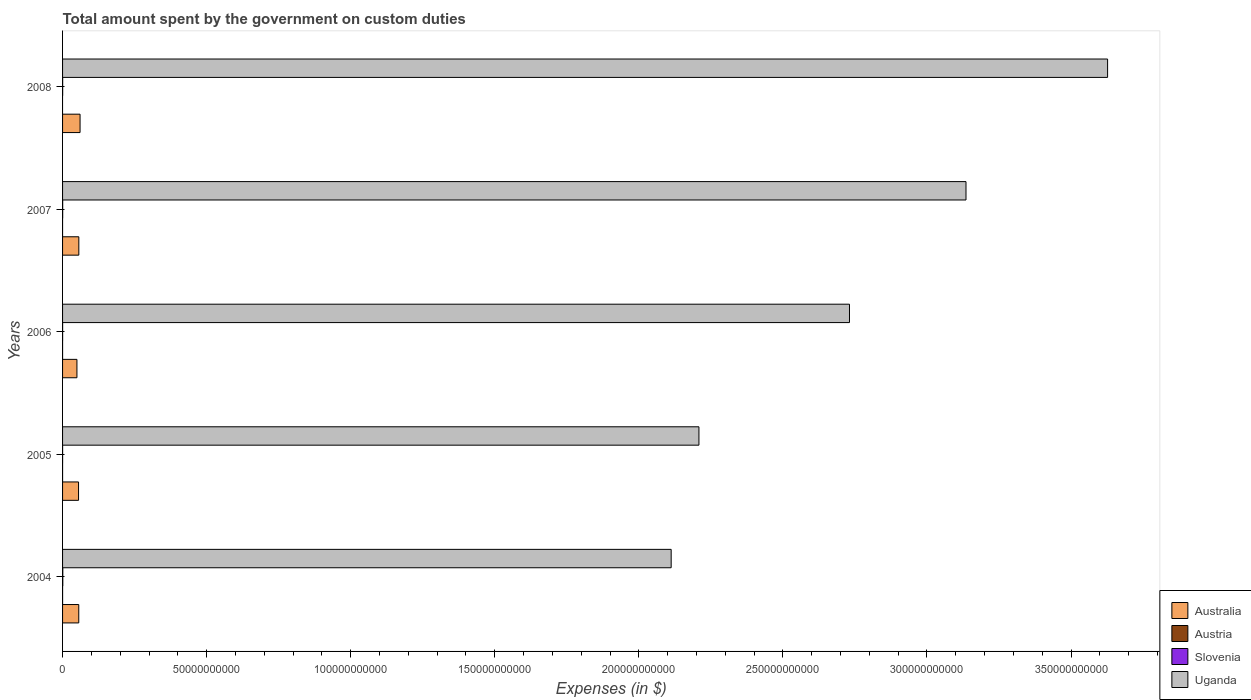Are the number of bars per tick equal to the number of legend labels?
Your response must be concise. No. Are the number of bars on each tick of the Y-axis equal?
Ensure brevity in your answer.  No. How many bars are there on the 3rd tick from the top?
Make the answer very short. 4. How many bars are there on the 3rd tick from the bottom?
Your answer should be compact. 4. What is the label of the 4th group of bars from the top?
Keep it short and to the point. 2005. What is the amount spent on custom duties by the government in Uganda in 2008?
Keep it short and to the point. 3.63e+11. Across all years, what is the maximum amount spent on custom duties by the government in Austria?
Provide a succinct answer. 3.94e+06. Across all years, what is the minimum amount spent on custom duties by the government in Australia?
Your answer should be very brief. 4.99e+09. In which year was the amount spent on custom duties by the government in Uganda maximum?
Keep it short and to the point. 2008. What is the total amount spent on custom duties by the government in Slovenia in the graph?
Your answer should be compact. 1.71e+08. What is the difference between the amount spent on custom duties by the government in Australia in 2004 and that in 2007?
Make the answer very short. -2.20e+07. What is the difference between the amount spent on custom duties by the government in Slovenia in 2006 and the amount spent on custom duties by the government in Australia in 2008?
Ensure brevity in your answer.  -6.05e+09. What is the average amount spent on custom duties by the government in Uganda per year?
Offer a terse response. 2.76e+11. In the year 2005, what is the difference between the amount spent on custom duties by the government in Uganda and amount spent on custom duties by the government in Austria?
Ensure brevity in your answer.  2.21e+11. In how many years, is the amount spent on custom duties by the government in Austria greater than 160000000000 $?
Your response must be concise. 0. What is the ratio of the amount spent on custom duties by the government in Slovenia in 2004 to that in 2005?
Your answer should be very brief. 7.57. Is the amount spent on custom duties by the government in Slovenia in 2004 less than that in 2007?
Your answer should be compact. No. What is the difference between the highest and the second highest amount spent on custom duties by the government in Slovenia?
Ensure brevity in your answer.  4.62e+07. What is the difference between the highest and the lowest amount spent on custom duties by the government in Austria?
Provide a short and direct response. 3.94e+06. In how many years, is the amount spent on custom duties by the government in Austria greater than the average amount spent on custom duties by the government in Austria taken over all years?
Offer a very short reply. 2. Is the sum of the amount spent on custom duties by the government in Uganda in 2005 and 2006 greater than the maximum amount spent on custom duties by the government in Austria across all years?
Offer a terse response. Yes. Is it the case that in every year, the sum of the amount spent on custom duties by the government in Slovenia and amount spent on custom duties by the government in Austria is greater than the amount spent on custom duties by the government in Uganda?
Provide a short and direct response. No. Are the values on the major ticks of X-axis written in scientific E-notation?
Provide a succinct answer. No. How many legend labels are there?
Your answer should be compact. 4. How are the legend labels stacked?
Provide a short and direct response. Vertical. What is the title of the graph?
Your answer should be compact. Total amount spent by the government on custom duties. Does "Solomon Islands" appear as one of the legend labels in the graph?
Provide a short and direct response. No. What is the label or title of the X-axis?
Your response must be concise. Expenses (in $). What is the Expenses (in $) of Australia in 2004?
Offer a very short reply. 5.62e+09. What is the Expenses (in $) of Austria in 2004?
Give a very brief answer. 3.94e+06. What is the Expenses (in $) in Slovenia in 2004?
Provide a succinct answer. 8.07e+07. What is the Expenses (in $) in Uganda in 2004?
Provide a succinct answer. 2.11e+11. What is the Expenses (in $) of Australia in 2005?
Provide a short and direct response. 5.55e+09. What is the Expenses (in $) of Austria in 2005?
Make the answer very short. 1.43e+06. What is the Expenses (in $) of Slovenia in 2005?
Ensure brevity in your answer.  1.07e+07. What is the Expenses (in $) of Uganda in 2005?
Provide a succinct answer. 2.21e+11. What is the Expenses (in $) of Australia in 2006?
Your answer should be very brief. 4.99e+09. What is the Expenses (in $) of Austria in 2006?
Keep it short and to the point. 7.00e+04. What is the Expenses (in $) in Slovenia in 2006?
Offer a terse response. 1.52e+07. What is the Expenses (in $) in Uganda in 2006?
Provide a short and direct response. 2.73e+11. What is the Expenses (in $) in Australia in 2007?
Offer a terse response. 5.64e+09. What is the Expenses (in $) in Slovenia in 2007?
Your answer should be very brief. 3.45e+07. What is the Expenses (in $) in Uganda in 2007?
Offer a very short reply. 3.14e+11. What is the Expenses (in $) in Australia in 2008?
Provide a succinct answer. 6.07e+09. What is the Expenses (in $) of Austria in 2008?
Your response must be concise. 0. What is the Expenses (in $) in Slovenia in 2008?
Give a very brief answer. 3.00e+07. What is the Expenses (in $) of Uganda in 2008?
Offer a terse response. 3.63e+11. Across all years, what is the maximum Expenses (in $) in Australia?
Ensure brevity in your answer.  6.07e+09. Across all years, what is the maximum Expenses (in $) of Austria?
Your answer should be very brief. 3.94e+06. Across all years, what is the maximum Expenses (in $) in Slovenia?
Give a very brief answer. 8.07e+07. Across all years, what is the maximum Expenses (in $) in Uganda?
Make the answer very short. 3.63e+11. Across all years, what is the minimum Expenses (in $) of Australia?
Provide a short and direct response. 4.99e+09. Across all years, what is the minimum Expenses (in $) in Slovenia?
Provide a short and direct response. 1.07e+07. Across all years, what is the minimum Expenses (in $) of Uganda?
Provide a short and direct response. 2.11e+11. What is the total Expenses (in $) of Australia in the graph?
Give a very brief answer. 2.79e+1. What is the total Expenses (in $) of Austria in the graph?
Provide a short and direct response. 5.44e+06. What is the total Expenses (in $) in Slovenia in the graph?
Your answer should be very brief. 1.71e+08. What is the total Expenses (in $) of Uganda in the graph?
Your answer should be compact. 1.38e+12. What is the difference between the Expenses (in $) of Australia in 2004 and that in 2005?
Your answer should be very brief. 7.40e+07. What is the difference between the Expenses (in $) of Austria in 2004 and that in 2005?
Your answer should be compact. 2.51e+06. What is the difference between the Expenses (in $) of Slovenia in 2004 and that in 2005?
Provide a short and direct response. 7.00e+07. What is the difference between the Expenses (in $) of Uganda in 2004 and that in 2005?
Offer a very short reply. -9.64e+09. What is the difference between the Expenses (in $) in Australia in 2004 and that in 2006?
Provide a short and direct response. 6.34e+08. What is the difference between the Expenses (in $) in Austria in 2004 and that in 2006?
Your answer should be very brief. 3.87e+06. What is the difference between the Expenses (in $) in Slovenia in 2004 and that in 2006?
Your answer should be very brief. 6.55e+07. What is the difference between the Expenses (in $) in Uganda in 2004 and that in 2006?
Keep it short and to the point. -6.19e+1. What is the difference between the Expenses (in $) in Australia in 2004 and that in 2007?
Offer a very short reply. -2.20e+07. What is the difference between the Expenses (in $) in Slovenia in 2004 and that in 2007?
Provide a short and direct response. 4.62e+07. What is the difference between the Expenses (in $) in Uganda in 2004 and that in 2007?
Keep it short and to the point. -1.02e+11. What is the difference between the Expenses (in $) in Australia in 2004 and that in 2008?
Offer a terse response. -4.48e+08. What is the difference between the Expenses (in $) in Slovenia in 2004 and that in 2008?
Provide a succinct answer. 5.07e+07. What is the difference between the Expenses (in $) of Uganda in 2004 and that in 2008?
Give a very brief answer. -1.51e+11. What is the difference between the Expenses (in $) in Australia in 2005 and that in 2006?
Keep it short and to the point. 5.60e+08. What is the difference between the Expenses (in $) of Austria in 2005 and that in 2006?
Make the answer very short. 1.36e+06. What is the difference between the Expenses (in $) in Slovenia in 2005 and that in 2006?
Give a very brief answer. -4.50e+06. What is the difference between the Expenses (in $) in Uganda in 2005 and that in 2006?
Your answer should be compact. -5.22e+1. What is the difference between the Expenses (in $) of Australia in 2005 and that in 2007?
Your answer should be very brief. -9.60e+07. What is the difference between the Expenses (in $) in Slovenia in 2005 and that in 2007?
Make the answer very short. -2.39e+07. What is the difference between the Expenses (in $) in Uganda in 2005 and that in 2007?
Your response must be concise. -9.27e+1. What is the difference between the Expenses (in $) of Australia in 2005 and that in 2008?
Provide a succinct answer. -5.22e+08. What is the difference between the Expenses (in $) in Slovenia in 2005 and that in 2008?
Make the answer very short. -1.94e+07. What is the difference between the Expenses (in $) in Uganda in 2005 and that in 2008?
Your response must be concise. -1.42e+11. What is the difference between the Expenses (in $) in Australia in 2006 and that in 2007?
Your answer should be compact. -6.56e+08. What is the difference between the Expenses (in $) in Slovenia in 2006 and that in 2007?
Provide a succinct answer. -1.94e+07. What is the difference between the Expenses (in $) of Uganda in 2006 and that in 2007?
Ensure brevity in your answer.  -4.04e+1. What is the difference between the Expenses (in $) of Australia in 2006 and that in 2008?
Keep it short and to the point. -1.08e+09. What is the difference between the Expenses (in $) of Slovenia in 2006 and that in 2008?
Provide a succinct answer. -1.49e+07. What is the difference between the Expenses (in $) in Uganda in 2006 and that in 2008?
Your answer should be very brief. -8.96e+1. What is the difference between the Expenses (in $) of Australia in 2007 and that in 2008?
Offer a very short reply. -4.26e+08. What is the difference between the Expenses (in $) in Slovenia in 2007 and that in 2008?
Your answer should be compact. 4.51e+06. What is the difference between the Expenses (in $) of Uganda in 2007 and that in 2008?
Offer a terse response. -4.91e+1. What is the difference between the Expenses (in $) of Australia in 2004 and the Expenses (in $) of Austria in 2005?
Your answer should be very brief. 5.62e+09. What is the difference between the Expenses (in $) in Australia in 2004 and the Expenses (in $) in Slovenia in 2005?
Provide a short and direct response. 5.61e+09. What is the difference between the Expenses (in $) in Australia in 2004 and the Expenses (in $) in Uganda in 2005?
Ensure brevity in your answer.  -2.15e+11. What is the difference between the Expenses (in $) of Austria in 2004 and the Expenses (in $) of Slovenia in 2005?
Provide a succinct answer. -6.72e+06. What is the difference between the Expenses (in $) in Austria in 2004 and the Expenses (in $) in Uganda in 2005?
Keep it short and to the point. -2.21e+11. What is the difference between the Expenses (in $) of Slovenia in 2004 and the Expenses (in $) of Uganda in 2005?
Your answer should be compact. -2.21e+11. What is the difference between the Expenses (in $) of Australia in 2004 and the Expenses (in $) of Austria in 2006?
Give a very brief answer. 5.62e+09. What is the difference between the Expenses (in $) in Australia in 2004 and the Expenses (in $) in Slovenia in 2006?
Make the answer very short. 5.61e+09. What is the difference between the Expenses (in $) of Australia in 2004 and the Expenses (in $) of Uganda in 2006?
Offer a terse response. -2.67e+11. What is the difference between the Expenses (in $) of Austria in 2004 and the Expenses (in $) of Slovenia in 2006?
Give a very brief answer. -1.12e+07. What is the difference between the Expenses (in $) in Austria in 2004 and the Expenses (in $) in Uganda in 2006?
Keep it short and to the point. -2.73e+11. What is the difference between the Expenses (in $) in Slovenia in 2004 and the Expenses (in $) in Uganda in 2006?
Your answer should be very brief. -2.73e+11. What is the difference between the Expenses (in $) in Australia in 2004 and the Expenses (in $) in Slovenia in 2007?
Provide a succinct answer. 5.59e+09. What is the difference between the Expenses (in $) in Australia in 2004 and the Expenses (in $) in Uganda in 2007?
Your response must be concise. -3.08e+11. What is the difference between the Expenses (in $) in Austria in 2004 and the Expenses (in $) in Slovenia in 2007?
Your answer should be compact. -3.06e+07. What is the difference between the Expenses (in $) of Austria in 2004 and the Expenses (in $) of Uganda in 2007?
Keep it short and to the point. -3.14e+11. What is the difference between the Expenses (in $) of Slovenia in 2004 and the Expenses (in $) of Uganda in 2007?
Make the answer very short. -3.13e+11. What is the difference between the Expenses (in $) in Australia in 2004 and the Expenses (in $) in Slovenia in 2008?
Offer a terse response. 5.59e+09. What is the difference between the Expenses (in $) in Australia in 2004 and the Expenses (in $) in Uganda in 2008?
Ensure brevity in your answer.  -3.57e+11. What is the difference between the Expenses (in $) in Austria in 2004 and the Expenses (in $) in Slovenia in 2008?
Provide a succinct answer. -2.61e+07. What is the difference between the Expenses (in $) in Austria in 2004 and the Expenses (in $) in Uganda in 2008?
Offer a terse response. -3.63e+11. What is the difference between the Expenses (in $) in Slovenia in 2004 and the Expenses (in $) in Uganda in 2008?
Offer a very short reply. -3.63e+11. What is the difference between the Expenses (in $) of Australia in 2005 and the Expenses (in $) of Austria in 2006?
Make the answer very short. 5.55e+09. What is the difference between the Expenses (in $) of Australia in 2005 and the Expenses (in $) of Slovenia in 2006?
Ensure brevity in your answer.  5.53e+09. What is the difference between the Expenses (in $) in Australia in 2005 and the Expenses (in $) in Uganda in 2006?
Your answer should be compact. -2.68e+11. What is the difference between the Expenses (in $) of Austria in 2005 and the Expenses (in $) of Slovenia in 2006?
Provide a short and direct response. -1.37e+07. What is the difference between the Expenses (in $) of Austria in 2005 and the Expenses (in $) of Uganda in 2006?
Offer a very short reply. -2.73e+11. What is the difference between the Expenses (in $) in Slovenia in 2005 and the Expenses (in $) in Uganda in 2006?
Your response must be concise. -2.73e+11. What is the difference between the Expenses (in $) of Australia in 2005 and the Expenses (in $) of Slovenia in 2007?
Ensure brevity in your answer.  5.51e+09. What is the difference between the Expenses (in $) of Australia in 2005 and the Expenses (in $) of Uganda in 2007?
Give a very brief answer. -3.08e+11. What is the difference between the Expenses (in $) in Austria in 2005 and the Expenses (in $) in Slovenia in 2007?
Offer a terse response. -3.31e+07. What is the difference between the Expenses (in $) in Austria in 2005 and the Expenses (in $) in Uganda in 2007?
Your response must be concise. -3.14e+11. What is the difference between the Expenses (in $) in Slovenia in 2005 and the Expenses (in $) in Uganda in 2007?
Your answer should be compact. -3.14e+11. What is the difference between the Expenses (in $) in Australia in 2005 and the Expenses (in $) in Slovenia in 2008?
Offer a very short reply. 5.52e+09. What is the difference between the Expenses (in $) of Australia in 2005 and the Expenses (in $) of Uganda in 2008?
Provide a short and direct response. -3.57e+11. What is the difference between the Expenses (in $) in Austria in 2005 and the Expenses (in $) in Slovenia in 2008?
Ensure brevity in your answer.  -2.86e+07. What is the difference between the Expenses (in $) of Austria in 2005 and the Expenses (in $) of Uganda in 2008?
Keep it short and to the point. -3.63e+11. What is the difference between the Expenses (in $) of Slovenia in 2005 and the Expenses (in $) of Uganda in 2008?
Offer a terse response. -3.63e+11. What is the difference between the Expenses (in $) in Australia in 2006 and the Expenses (in $) in Slovenia in 2007?
Ensure brevity in your answer.  4.95e+09. What is the difference between the Expenses (in $) in Australia in 2006 and the Expenses (in $) in Uganda in 2007?
Your response must be concise. -3.09e+11. What is the difference between the Expenses (in $) of Austria in 2006 and the Expenses (in $) of Slovenia in 2007?
Provide a short and direct response. -3.45e+07. What is the difference between the Expenses (in $) of Austria in 2006 and the Expenses (in $) of Uganda in 2007?
Your answer should be very brief. -3.14e+11. What is the difference between the Expenses (in $) in Slovenia in 2006 and the Expenses (in $) in Uganda in 2007?
Your response must be concise. -3.14e+11. What is the difference between the Expenses (in $) in Australia in 2006 and the Expenses (in $) in Slovenia in 2008?
Your response must be concise. 4.96e+09. What is the difference between the Expenses (in $) in Australia in 2006 and the Expenses (in $) in Uganda in 2008?
Offer a terse response. -3.58e+11. What is the difference between the Expenses (in $) of Austria in 2006 and the Expenses (in $) of Slovenia in 2008?
Make the answer very short. -3.00e+07. What is the difference between the Expenses (in $) of Austria in 2006 and the Expenses (in $) of Uganda in 2008?
Your answer should be very brief. -3.63e+11. What is the difference between the Expenses (in $) in Slovenia in 2006 and the Expenses (in $) in Uganda in 2008?
Keep it short and to the point. -3.63e+11. What is the difference between the Expenses (in $) in Australia in 2007 and the Expenses (in $) in Slovenia in 2008?
Make the answer very short. 5.61e+09. What is the difference between the Expenses (in $) in Australia in 2007 and the Expenses (in $) in Uganda in 2008?
Your response must be concise. -3.57e+11. What is the difference between the Expenses (in $) in Slovenia in 2007 and the Expenses (in $) in Uganda in 2008?
Make the answer very short. -3.63e+11. What is the average Expenses (in $) in Australia per year?
Ensure brevity in your answer.  5.57e+09. What is the average Expenses (in $) in Austria per year?
Offer a very short reply. 1.09e+06. What is the average Expenses (in $) of Slovenia per year?
Your response must be concise. 3.42e+07. What is the average Expenses (in $) of Uganda per year?
Offer a very short reply. 2.76e+11. In the year 2004, what is the difference between the Expenses (in $) of Australia and Expenses (in $) of Austria?
Provide a succinct answer. 5.62e+09. In the year 2004, what is the difference between the Expenses (in $) of Australia and Expenses (in $) of Slovenia?
Provide a short and direct response. 5.54e+09. In the year 2004, what is the difference between the Expenses (in $) of Australia and Expenses (in $) of Uganda?
Make the answer very short. -2.06e+11. In the year 2004, what is the difference between the Expenses (in $) in Austria and Expenses (in $) in Slovenia?
Your answer should be compact. -7.68e+07. In the year 2004, what is the difference between the Expenses (in $) in Austria and Expenses (in $) in Uganda?
Offer a terse response. -2.11e+11. In the year 2004, what is the difference between the Expenses (in $) of Slovenia and Expenses (in $) of Uganda?
Your response must be concise. -2.11e+11. In the year 2005, what is the difference between the Expenses (in $) of Australia and Expenses (in $) of Austria?
Your answer should be very brief. 5.55e+09. In the year 2005, what is the difference between the Expenses (in $) in Australia and Expenses (in $) in Slovenia?
Make the answer very short. 5.54e+09. In the year 2005, what is the difference between the Expenses (in $) of Australia and Expenses (in $) of Uganda?
Ensure brevity in your answer.  -2.15e+11. In the year 2005, what is the difference between the Expenses (in $) of Austria and Expenses (in $) of Slovenia?
Offer a terse response. -9.23e+06. In the year 2005, what is the difference between the Expenses (in $) of Austria and Expenses (in $) of Uganda?
Provide a short and direct response. -2.21e+11. In the year 2005, what is the difference between the Expenses (in $) of Slovenia and Expenses (in $) of Uganda?
Your response must be concise. -2.21e+11. In the year 2006, what is the difference between the Expenses (in $) in Australia and Expenses (in $) in Austria?
Give a very brief answer. 4.99e+09. In the year 2006, what is the difference between the Expenses (in $) in Australia and Expenses (in $) in Slovenia?
Your answer should be very brief. 4.97e+09. In the year 2006, what is the difference between the Expenses (in $) of Australia and Expenses (in $) of Uganda?
Offer a very short reply. -2.68e+11. In the year 2006, what is the difference between the Expenses (in $) in Austria and Expenses (in $) in Slovenia?
Offer a terse response. -1.51e+07. In the year 2006, what is the difference between the Expenses (in $) in Austria and Expenses (in $) in Uganda?
Your answer should be compact. -2.73e+11. In the year 2006, what is the difference between the Expenses (in $) of Slovenia and Expenses (in $) of Uganda?
Offer a terse response. -2.73e+11. In the year 2007, what is the difference between the Expenses (in $) of Australia and Expenses (in $) of Slovenia?
Your answer should be compact. 5.61e+09. In the year 2007, what is the difference between the Expenses (in $) in Australia and Expenses (in $) in Uganda?
Offer a terse response. -3.08e+11. In the year 2007, what is the difference between the Expenses (in $) of Slovenia and Expenses (in $) of Uganda?
Offer a terse response. -3.14e+11. In the year 2008, what is the difference between the Expenses (in $) in Australia and Expenses (in $) in Slovenia?
Offer a terse response. 6.04e+09. In the year 2008, what is the difference between the Expenses (in $) of Australia and Expenses (in $) of Uganda?
Make the answer very short. -3.57e+11. In the year 2008, what is the difference between the Expenses (in $) of Slovenia and Expenses (in $) of Uganda?
Offer a terse response. -3.63e+11. What is the ratio of the Expenses (in $) of Australia in 2004 to that in 2005?
Make the answer very short. 1.01. What is the ratio of the Expenses (in $) of Austria in 2004 to that in 2005?
Your answer should be compact. 2.76. What is the ratio of the Expenses (in $) in Slovenia in 2004 to that in 2005?
Provide a short and direct response. 7.57. What is the ratio of the Expenses (in $) of Uganda in 2004 to that in 2005?
Offer a very short reply. 0.96. What is the ratio of the Expenses (in $) in Australia in 2004 to that in 2006?
Give a very brief answer. 1.13. What is the ratio of the Expenses (in $) of Austria in 2004 to that in 2006?
Ensure brevity in your answer.  56.29. What is the ratio of the Expenses (in $) of Slovenia in 2004 to that in 2006?
Give a very brief answer. 5.32. What is the ratio of the Expenses (in $) of Uganda in 2004 to that in 2006?
Keep it short and to the point. 0.77. What is the ratio of the Expenses (in $) in Australia in 2004 to that in 2007?
Give a very brief answer. 1. What is the ratio of the Expenses (in $) of Slovenia in 2004 to that in 2007?
Keep it short and to the point. 2.34. What is the ratio of the Expenses (in $) in Uganda in 2004 to that in 2007?
Offer a very short reply. 0.67. What is the ratio of the Expenses (in $) in Australia in 2004 to that in 2008?
Keep it short and to the point. 0.93. What is the ratio of the Expenses (in $) in Slovenia in 2004 to that in 2008?
Provide a succinct answer. 2.69. What is the ratio of the Expenses (in $) of Uganda in 2004 to that in 2008?
Provide a succinct answer. 0.58. What is the ratio of the Expenses (in $) in Australia in 2005 to that in 2006?
Make the answer very short. 1.11. What is the ratio of the Expenses (in $) in Austria in 2005 to that in 2006?
Provide a succinct answer. 20.43. What is the ratio of the Expenses (in $) in Slovenia in 2005 to that in 2006?
Make the answer very short. 0.7. What is the ratio of the Expenses (in $) of Uganda in 2005 to that in 2006?
Provide a succinct answer. 0.81. What is the ratio of the Expenses (in $) of Australia in 2005 to that in 2007?
Make the answer very short. 0.98. What is the ratio of the Expenses (in $) in Slovenia in 2005 to that in 2007?
Provide a short and direct response. 0.31. What is the ratio of the Expenses (in $) of Uganda in 2005 to that in 2007?
Your answer should be compact. 0.7. What is the ratio of the Expenses (in $) of Australia in 2005 to that in 2008?
Ensure brevity in your answer.  0.91. What is the ratio of the Expenses (in $) in Slovenia in 2005 to that in 2008?
Offer a very short reply. 0.36. What is the ratio of the Expenses (in $) in Uganda in 2005 to that in 2008?
Keep it short and to the point. 0.61. What is the ratio of the Expenses (in $) in Australia in 2006 to that in 2007?
Give a very brief answer. 0.88. What is the ratio of the Expenses (in $) in Slovenia in 2006 to that in 2007?
Ensure brevity in your answer.  0.44. What is the ratio of the Expenses (in $) in Uganda in 2006 to that in 2007?
Make the answer very short. 0.87. What is the ratio of the Expenses (in $) of Australia in 2006 to that in 2008?
Give a very brief answer. 0.82. What is the ratio of the Expenses (in $) in Slovenia in 2006 to that in 2008?
Offer a very short reply. 0.51. What is the ratio of the Expenses (in $) of Uganda in 2006 to that in 2008?
Provide a succinct answer. 0.75. What is the ratio of the Expenses (in $) of Australia in 2007 to that in 2008?
Keep it short and to the point. 0.93. What is the ratio of the Expenses (in $) in Slovenia in 2007 to that in 2008?
Give a very brief answer. 1.15. What is the ratio of the Expenses (in $) in Uganda in 2007 to that in 2008?
Your answer should be compact. 0.86. What is the difference between the highest and the second highest Expenses (in $) of Australia?
Keep it short and to the point. 4.26e+08. What is the difference between the highest and the second highest Expenses (in $) in Austria?
Make the answer very short. 2.51e+06. What is the difference between the highest and the second highest Expenses (in $) in Slovenia?
Provide a short and direct response. 4.62e+07. What is the difference between the highest and the second highest Expenses (in $) in Uganda?
Offer a very short reply. 4.91e+1. What is the difference between the highest and the lowest Expenses (in $) of Australia?
Provide a short and direct response. 1.08e+09. What is the difference between the highest and the lowest Expenses (in $) of Austria?
Provide a succinct answer. 3.94e+06. What is the difference between the highest and the lowest Expenses (in $) of Slovenia?
Ensure brevity in your answer.  7.00e+07. What is the difference between the highest and the lowest Expenses (in $) in Uganda?
Give a very brief answer. 1.51e+11. 